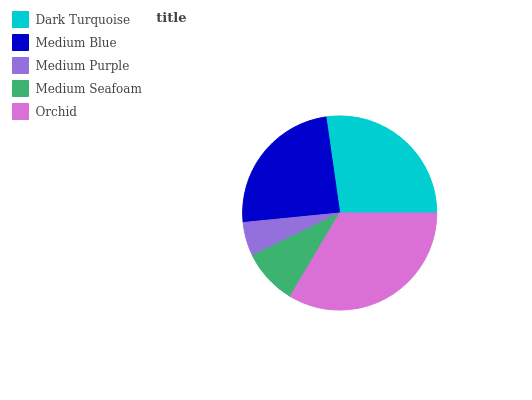Is Medium Purple the minimum?
Answer yes or no. Yes. Is Orchid the maximum?
Answer yes or no. Yes. Is Medium Blue the minimum?
Answer yes or no. No. Is Medium Blue the maximum?
Answer yes or no. No. Is Dark Turquoise greater than Medium Blue?
Answer yes or no. Yes. Is Medium Blue less than Dark Turquoise?
Answer yes or no. Yes. Is Medium Blue greater than Dark Turquoise?
Answer yes or no. No. Is Dark Turquoise less than Medium Blue?
Answer yes or no. No. Is Medium Blue the high median?
Answer yes or no. Yes. Is Medium Blue the low median?
Answer yes or no. Yes. Is Medium Seafoam the high median?
Answer yes or no. No. Is Dark Turquoise the low median?
Answer yes or no. No. 